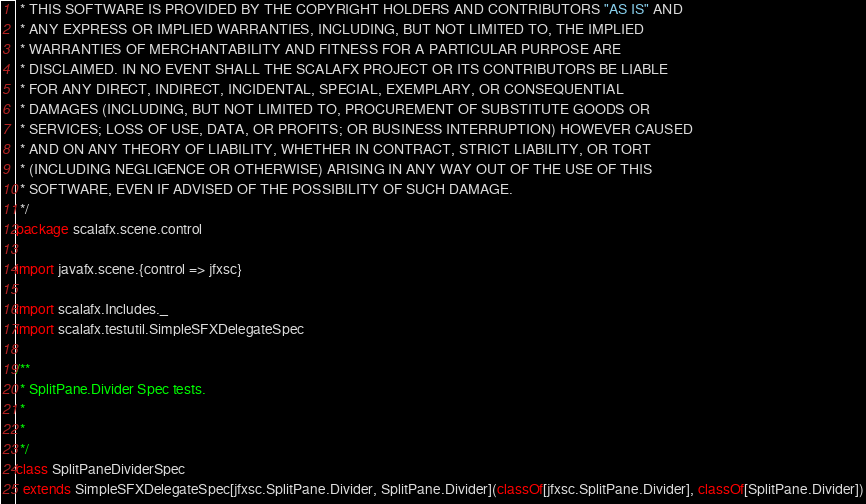Convert code to text. <code><loc_0><loc_0><loc_500><loc_500><_Scala_> * THIS SOFTWARE IS PROVIDED BY THE COPYRIGHT HOLDERS AND CONTRIBUTORS "AS IS" AND
 * ANY EXPRESS OR IMPLIED WARRANTIES, INCLUDING, BUT NOT LIMITED TO, THE IMPLIED
 * WARRANTIES OF MERCHANTABILITY AND FITNESS FOR A PARTICULAR PURPOSE ARE
 * DISCLAIMED. IN NO EVENT SHALL THE SCALAFX PROJECT OR ITS CONTRIBUTORS BE LIABLE
 * FOR ANY DIRECT, INDIRECT, INCIDENTAL, SPECIAL, EXEMPLARY, OR CONSEQUENTIAL
 * DAMAGES (INCLUDING, BUT NOT LIMITED TO, PROCUREMENT OF SUBSTITUTE GOODS OR
 * SERVICES; LOSS OF USE, DATA, OR PROFITS; OR BUSINESS INTERRUPTION) HOWEVER CAUSED
 * AND ON ANY THEORY OF LIABILITY, WHETHER IN CONTRACT, STRICT LIABILITY, OR TORT
 * (INCLUDING NEGLIGENCE OR OTHERWISE) ARISING IN ANY WAY OUT OF THE USE OF THIS
 * SOFTWARE, EVEN IF ADVISED OF THE POSSIBILITY OF SUCH DAMAGE.
 */
package scalafx.scene.control

import javafx.scene.{control => jfxsc}

import scalafx.Includes._
import scalafx.testutil.SimpleSFXDelegateSpec

/**
 * SplitPane.Divider Spec tests.
 *
 *
 */
class SplitPaneDividerSpec
  extends SimpleSFXDelegateSpec[jfxsc.SplitPane.Divider, SplitPane.Divider](classOf[jfxsc.SplitPane.Divider], classOf[SplitPane.Divider])
</code> 